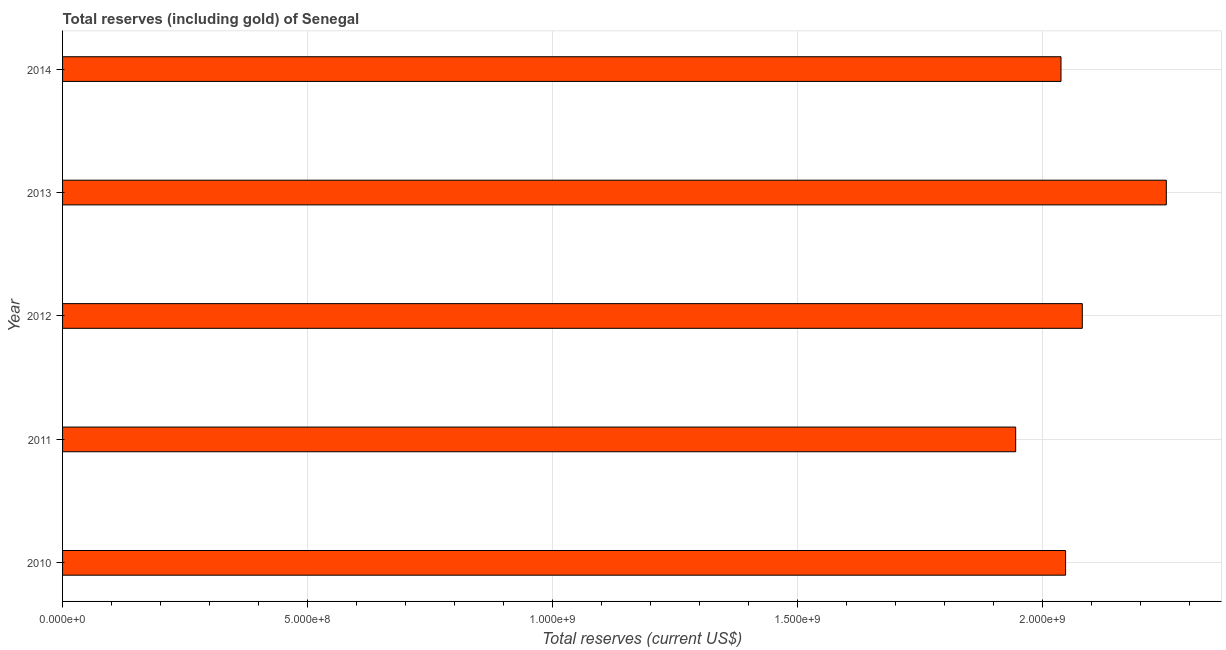Does the graph contain grids?
Ensure brevity in your answer.  Yes. What is the title of the graph?
Offer a terse response. Total reserves (including gold) of Senegal. What is the label or title of the X-axis?
Give a very brief answer. Total reserves (current US$). What is the total reserves (including gold) in 2014?
Your response must be concise. 2.04e+09. Across all years, what is the maximum total reserves (including gold)?
Provide a short and direct response. 2.25e+09. Across all years, what is the minimum total reserves (including gold)?
Provide a short and direct response. 1.95e+09. In which year was the total reserves (including gold) maximum?
Make the answer very short. 2013. What is the sum of the total reserves (including gold)?
Provide a succinct answer. 1.04e+1. What is the difference between the total reserves (including gold) in 2010 and 2011?
Your answer should be very brief. 1.02e+08. What is the average total reserves (including gold) per year?
Your answer should be very brief. 2.07e+09. What is the median total reserves (including gold)?
Your answer should be very brief. 2.05e+09. Is the total reserves (including gold) in 2013 less than that in 2014?
Your answer should be compact. No. What is the difference between the highest and the second highest total reserves (including gold)?
Keep it short and to the point. 1.71e+08. Is the sum of the total reserves (including gold) in 2011 and 2014 greater than the maximum total reserves (including gold) across all years?
Ensure brevity in your answer.  Yes. What is the difference between the highest and the lowest total reserves (including gold)?
Offer a terse response. 3.07e+08. In how many years, is the total reserves (including gold) greater than the average total reserves (including gold) taken over all years?
Make the answer very short. 2. How many bars are there?
Give a very brief answer. 5. Are all the bars in the graph horizontal?
Your answer should be very brief. Yes. What is the difference between two consecutive major ticks on the X-axis?
Offer a very short reply. 5.00e+08. What is the Total reserves (current US$) of 2010?
Keep it short and to the point. 2.05e+09. What is the Total reserves (current US$) of 2011?
Provide a short and direct response. 1.95e+09. What is the Total reserves (current US$) in 2012?
Make the answer very short. 2.08e+09. What is the Total reserves (current US$) of 2013?
Provide a short and direct response. 2.25e+09. What is the Total reserves (current US$) of 2014?
Offer a terse response. 2.04e+09. What is the difference between the Total reserves (current US$) in 2010 and 2011?
Your answer should be compact. 1.02e+08. What is the difference between the Total reserves (current US$) in 2010 and 2012?
Offer a very short reply. -3.41e+07. What is the difference between the Total reserves (current US$) in 2010 and 2013?
Keep it short and to the point. -2.06e+08. What is the difference between the Total reserves (current US$) in 2010 and 2014?
Give a very brief answer. 9.36e+06. What is the difference between the Total reserves (current US$) in 2011 and 2012?
Offer a very short reply. -1.36e+08. What is the difference between the Total reserves (current US$) in 2011 and 2013?
Offer a very short reply. -3.07e+08. What is the difference between the Total reserves (current US$) in 2011 and 2014?
Your answer should be very brief. -9.25e+07. What is the difference between the Total reserves (current US$) in 2012 and 2013?
Your response must be concise. -1.71e+08. What is the difference between the Total reserves (current US$) in 2012 and 2014?
Provide a short and direct response. 4.35e+07. What is the difference between the Total reserves (current US$) in 2013 and 2014?
Offer a very short reply. 2.15e+08. What is the ratio of the Total reserves (current US$) in 2010 to that in 2011?
Offer a very short reply. 1.05. What is the ratio of the Total reserves (current US$) in 2010 to that in 2013?
Give a very brief answer. 0.91. What is the ratio of the Total reserves (current US$) in 2010 to that in 2014?
Offer a very short reply. 1. What is the ratio of the Total reserves (current US$) in 2011 to that in 2012?
Give a very brief answer. 0.94. What is the ratio of the Total reserves (current US$) in 2011 to that in 2013?
Provide a succinct answer. 0.86. What is the ratio of the Total reserves (current US$) in 2011 to that in 2014?
Make the answer very short. 0.95. What is the ratio of the Total reserves (current US$) in 2012 to that in 2013?
Your response must be concise. 0.92. What is the ratio of the Total reserves (current US$) in 2013 to that in 2014?
Your response must be concise. 1.1. 